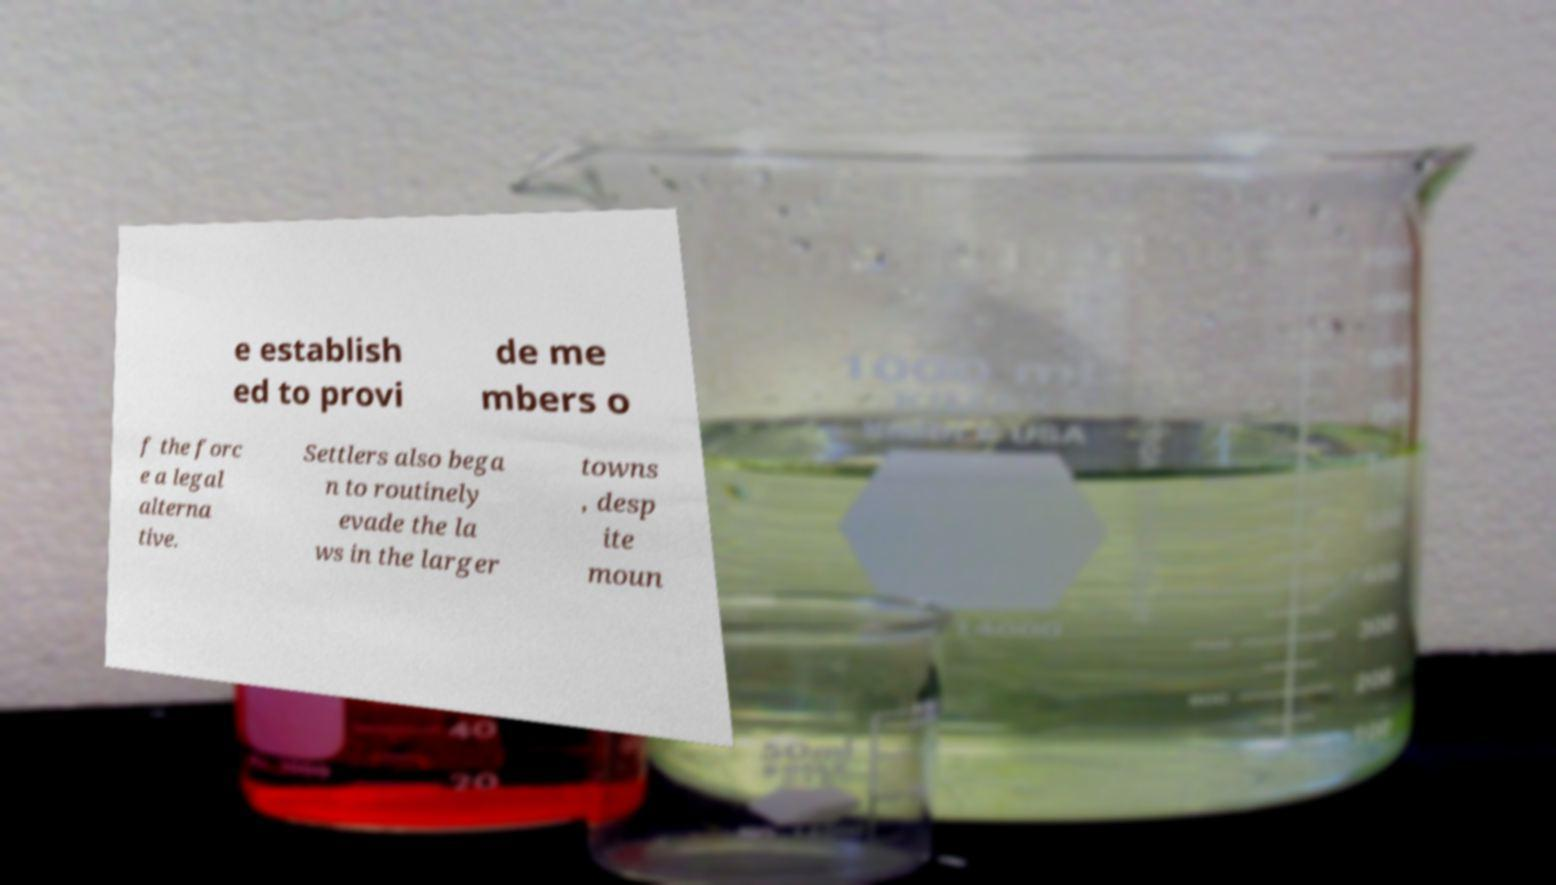Can you read and provide the text displayed in the image?This photo seems to have some interesting text. Can you extract and type it out for me? e establish ed to provi de me mbers o f the forc e a legal alterna tive. Settlers also bega n to routinely evade the la ws in the larger towns , desp ite moun 